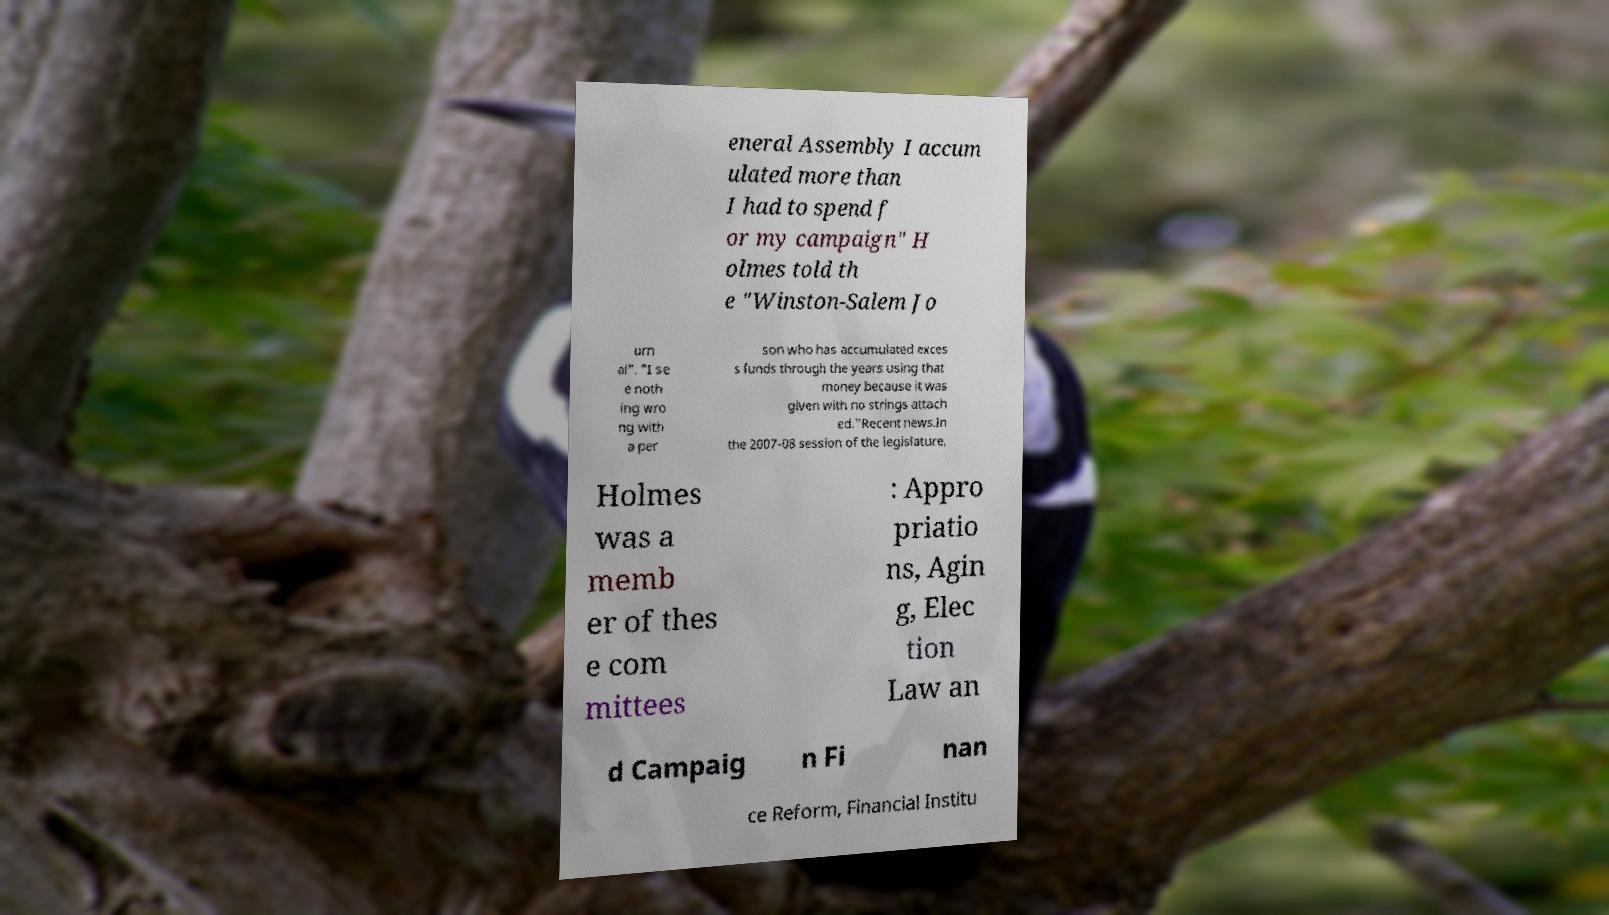What messages or text are displayed in this image? I need them in a readable, typed format. eneral Assembly I accum ulated more than I had to spend f or my campaign" H olmes told th e "Winston-Salem Jo urn al". "I se e noth ing wro ng with a per son who has accumulated exces s funds through the years using that money because it was given with no strings attach ed."Recent news.In the 2007-08 session of the legislature, Holmes was a memb er of thes e com mittees : Appro priatio ns, Agin g, Elec tion Law an d Campaig n Fi nan ce Reform, Financial Institu 